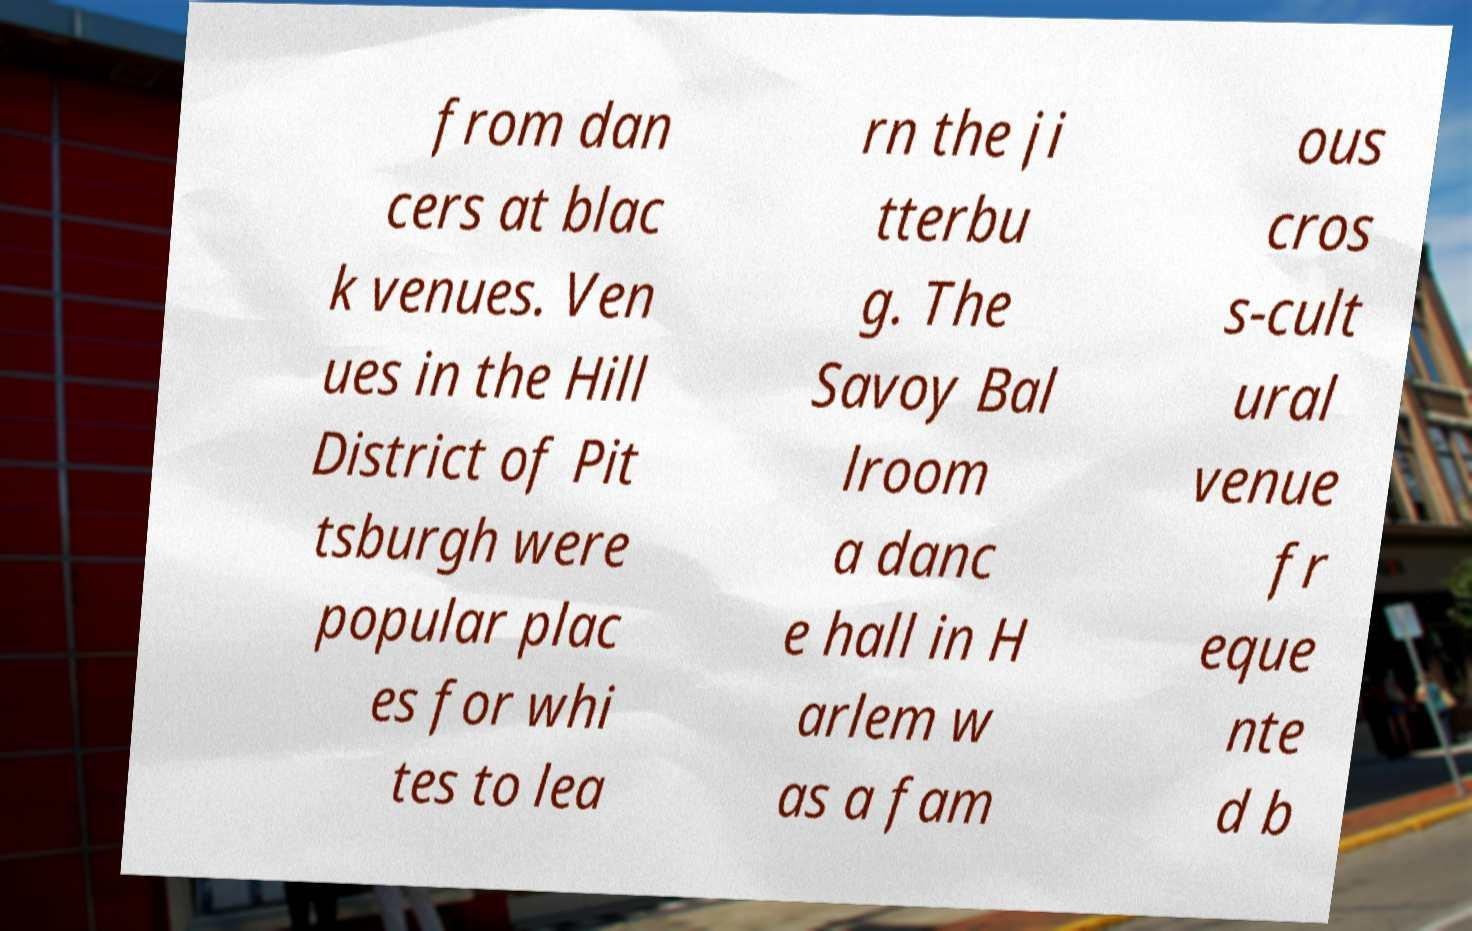Please read and relay the text visible in this image. What does it say? from dan cers at blac k venues. Ven ues in the Hill District of Pit tsburgh were popular plac es for whi tes to lea rn the ji tterbu g. The Savoy Bal lroom a danc e hall in H arlem w as a fam ous cros s-cult ural venue fr eque nte d b 